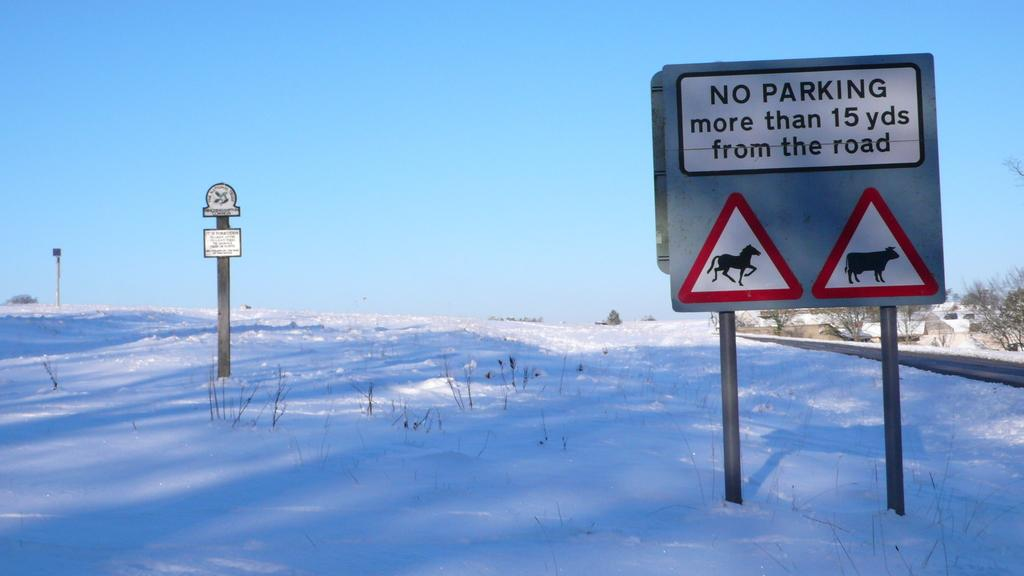Provide a one-sentence caption for the provided image. A sign states that people must not park more than 15 yards from the road. 